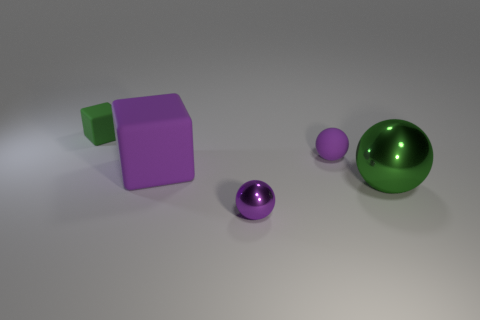Add 4 large rubber things. How many objects exist? 9 Subtract all purple matte balls. How many balls are left? 2 Subtract 1 spheres. How many spheres are left? 2 Subtract all green spheres. How many spheres are left? 2 Subtract all balls. How many objects are left? 2 Subtract all large yellow metal cylinders. Subtract all tiny purple matte things. How many objects are left? 4 Add 1 large balls. How many large balls are left? 2 Add 2 big blue objects. How many big blue objects exist? 2 Subtract 0 blue cylinders. How many objects are left? 5 Subtract all brown spheres. Subtract all blue blocks. How many spheres are left? 3 